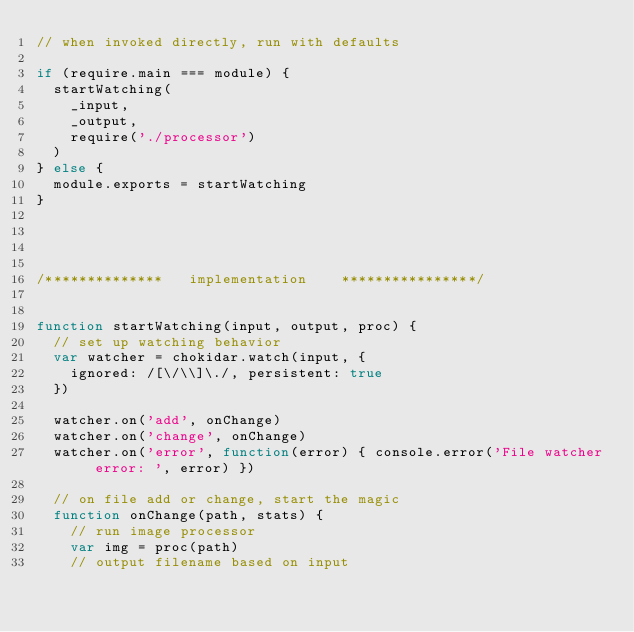<code> <loc_0><loc_0><loc_500><loc_500><_JavaScript_>// when invoked directly, run with defaults

if (require.main === module) {
	startWatching(
		_input,
		_output,
		require('./processor')
	)
} else {
	module.exports = startWatching
}




/**************   implementation    ****************/


function startWatching(input, output, proc) {
	// set up watching behavior
	var watcher = chokidar.watch(input, {
		ignored: /[\/\\]\./, persistent: true
	})

	watcher.on('add', onChange)
	watcher.on('change', onChange)
	watcher.on('error', function(error) { console.error('File watcher error: ', error) })

	// on file add or change, start the magic
	function onChange(path, stats) {
		// run image processor
		var img = proc(path)
		// output filename based on input</code> 